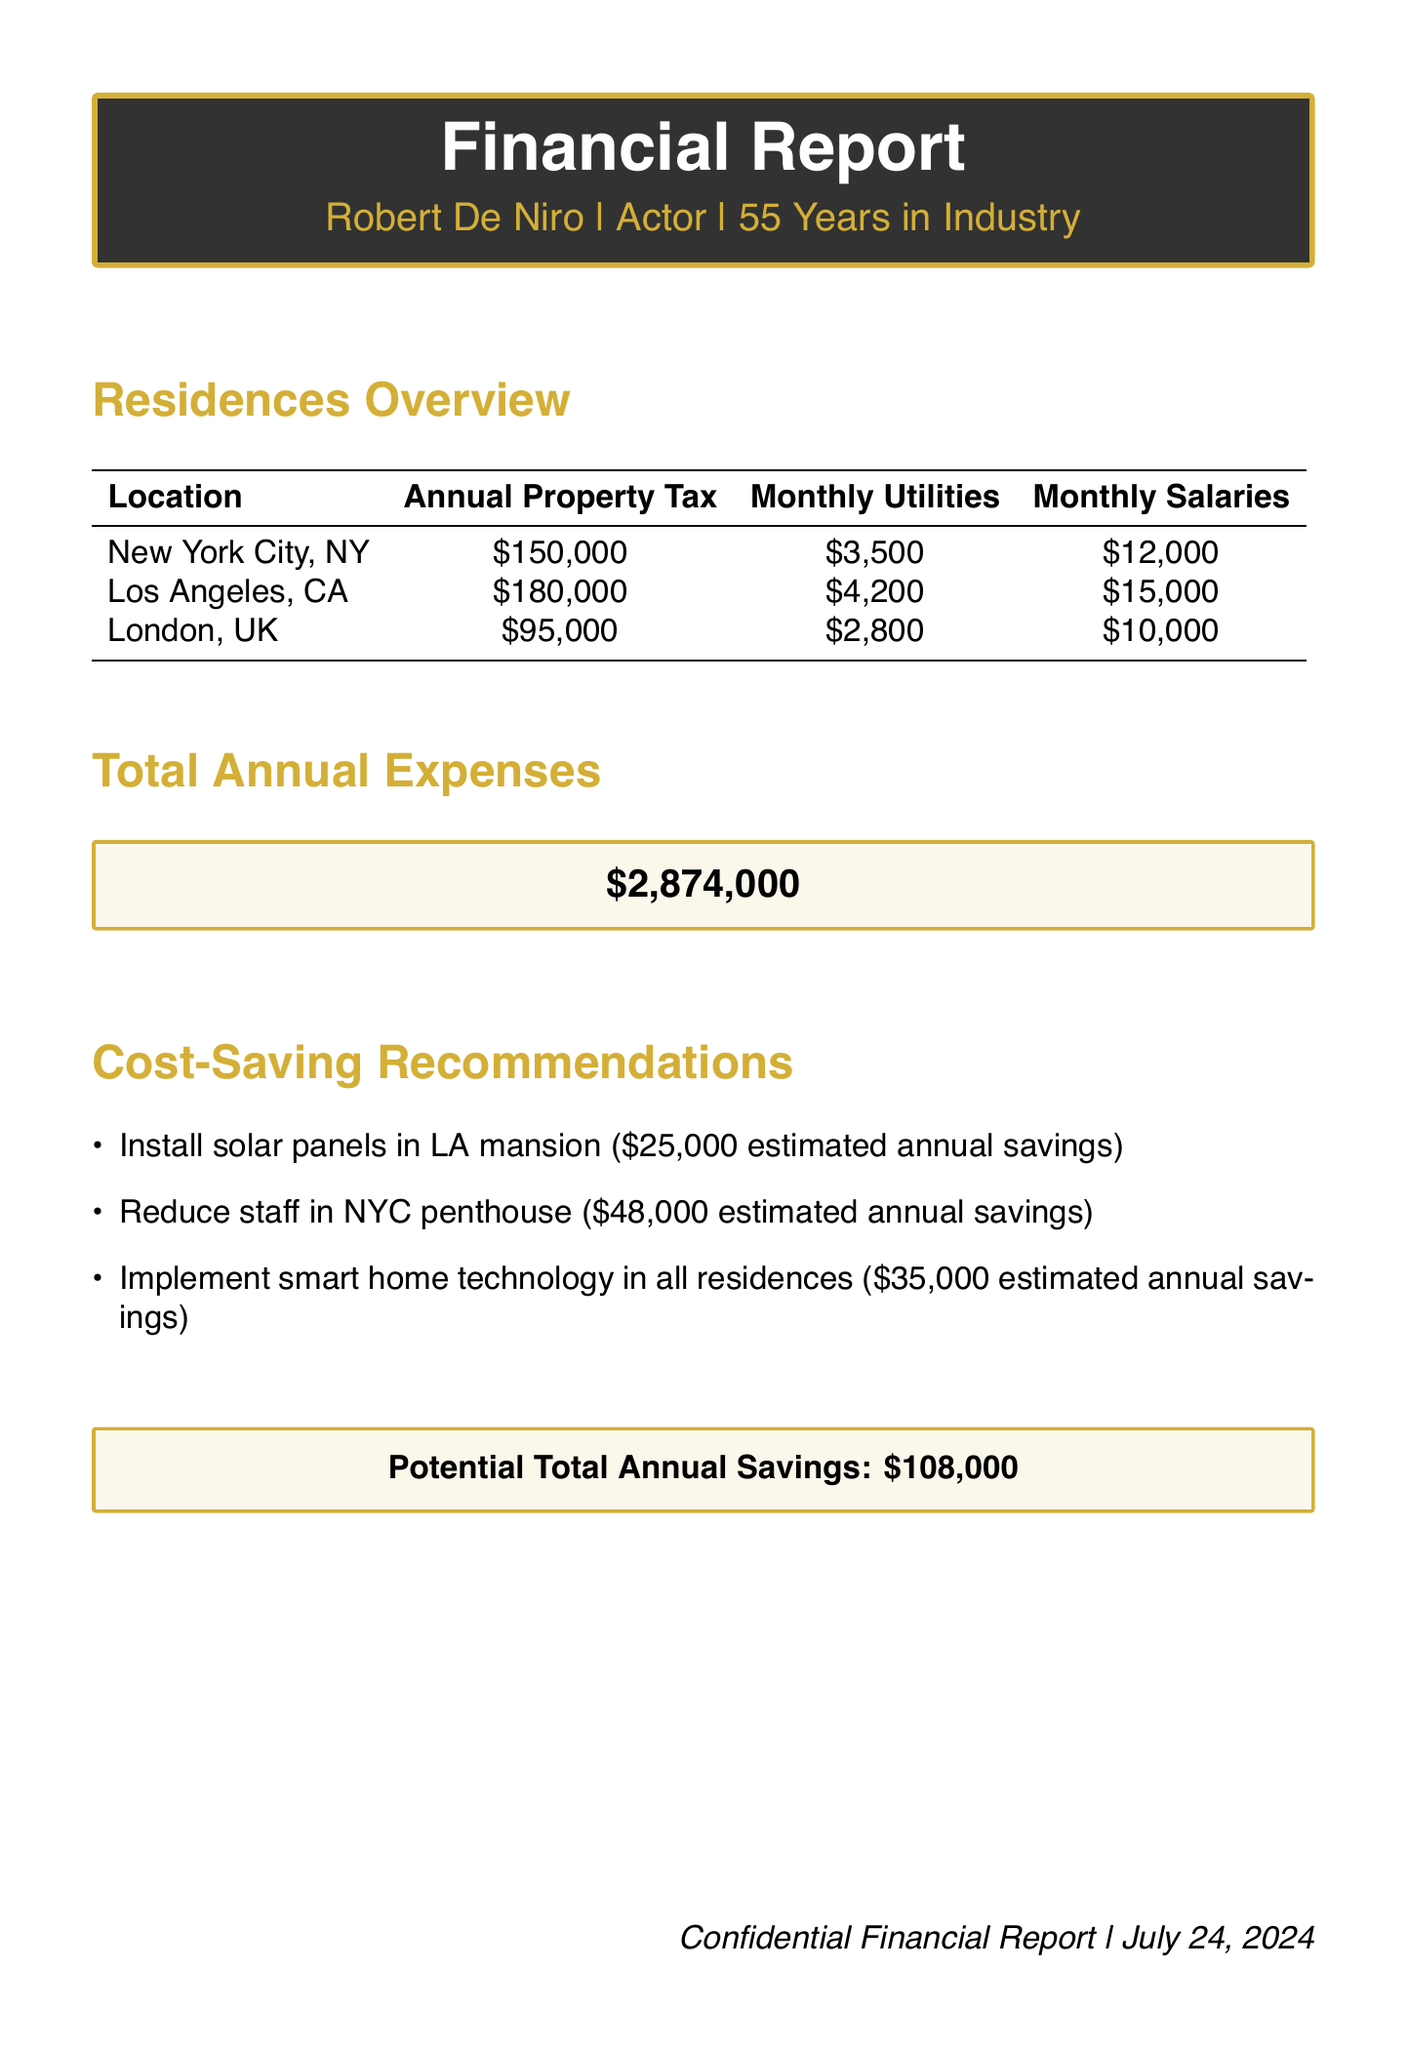What is the annual property tax for the New York City residence? The annual property tax for the New York City residence is listed in the table as $150,000.
Answer: $150,000 What is the estimated annual savings from reducing staff in the NYC penthouse? The estimated annual savings from reducing staff in the NYC penthouse is specified as $48,000.
Answer: $48,000 How much are the monthly utilities for the Los Angeles mansion? The monthly utilities for the Los Angeles mansion are mentioned as $4,200.
Answer: $4,200 What is the total annual expense reported in the document? The total annual expense reported is highlighted in a box as $2,874,000.
Answer: $2,874,000 Which residence has the lowest annual property tax? The residence with the lowest annual property tax can be determined by comparing the amounts listed, which is London, UK at $95,000.
Answer: London, UK What is the potential total annual savings from cost-saving recommendations? The potential total annual savings is stated in a box as $108,000.
Answer: $108,000 What technology is recommended to be implemented in all residences? The recommendation for all residences includes the implementation of smart home technology.
Answer: Smart home technology What is the location of the penthouse? The location of the penthouse is stated as New York City, NY.
Answer: New York City, NY 